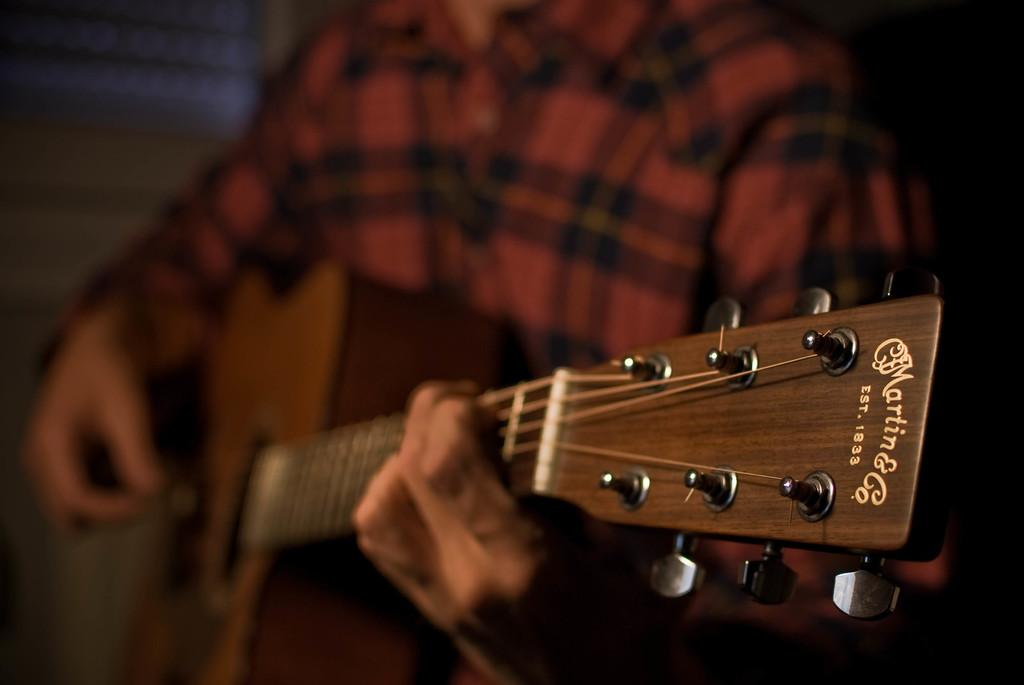What is the main subject of the image? There is a person in the image. What is the person doing in the image? The person is playing a guitar. Can you see any ladybugs on the guitar in the image? There are no ladybugs present in the image. What type of cracker is the person eating while playing the guitar in the image? There is no cracker visible in the image, and the person is not eating anything. 